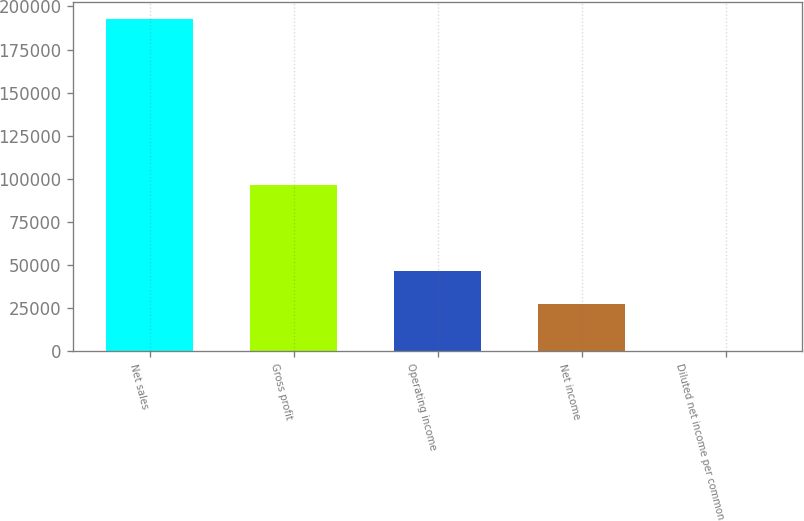Convert chart to OTSL. <chart><loc_0><loc_0><loc_500><loc_500><bar_chart><fcel>Net sales<fcel>Gross profit<fcel>Operating income<fcel>Net income<fcel>Diluted net income per common<nl><fcel>192949<fcel>96435<fcel>46662.9<fcel>27368<fcel>0.15<nl></chart> 